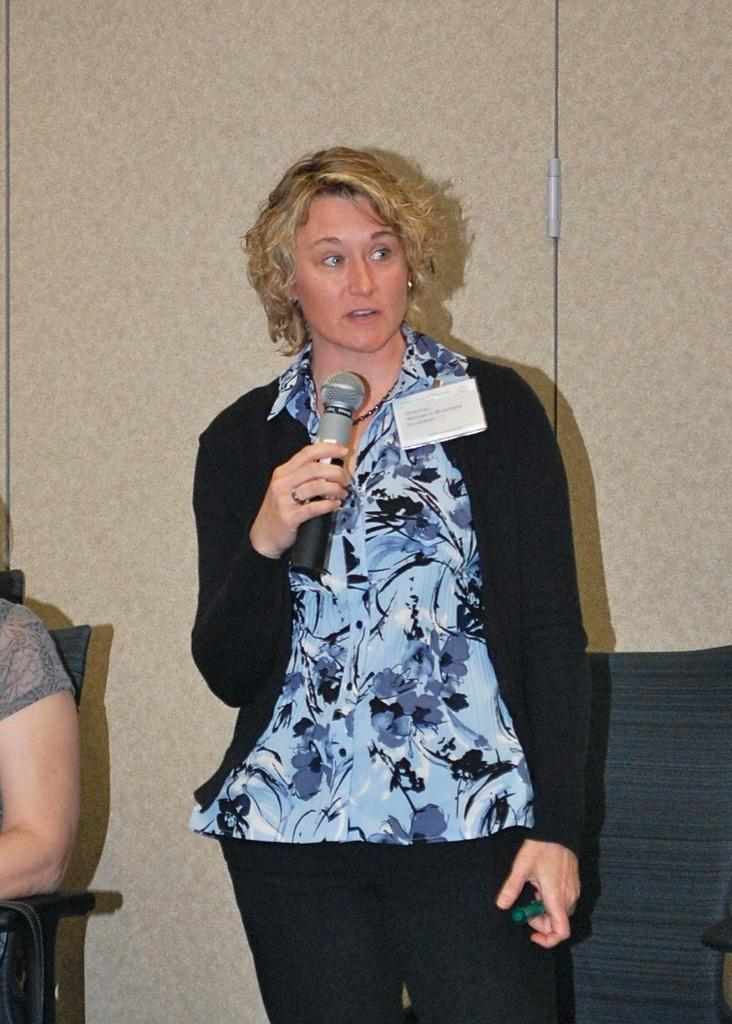What is the primary action of the woman in the image? The standing woman is speaking in the image. How is the standing woman using her hand? The standing woman is using her hand for gesturing while speaking. What is the seated woman's position in the image? The seated woman is on a chair in the image. What type of planes can be seen flying in the image? There are no planes visible in the image; it features two women, one standing and speaking, and the other seated on a chair. 